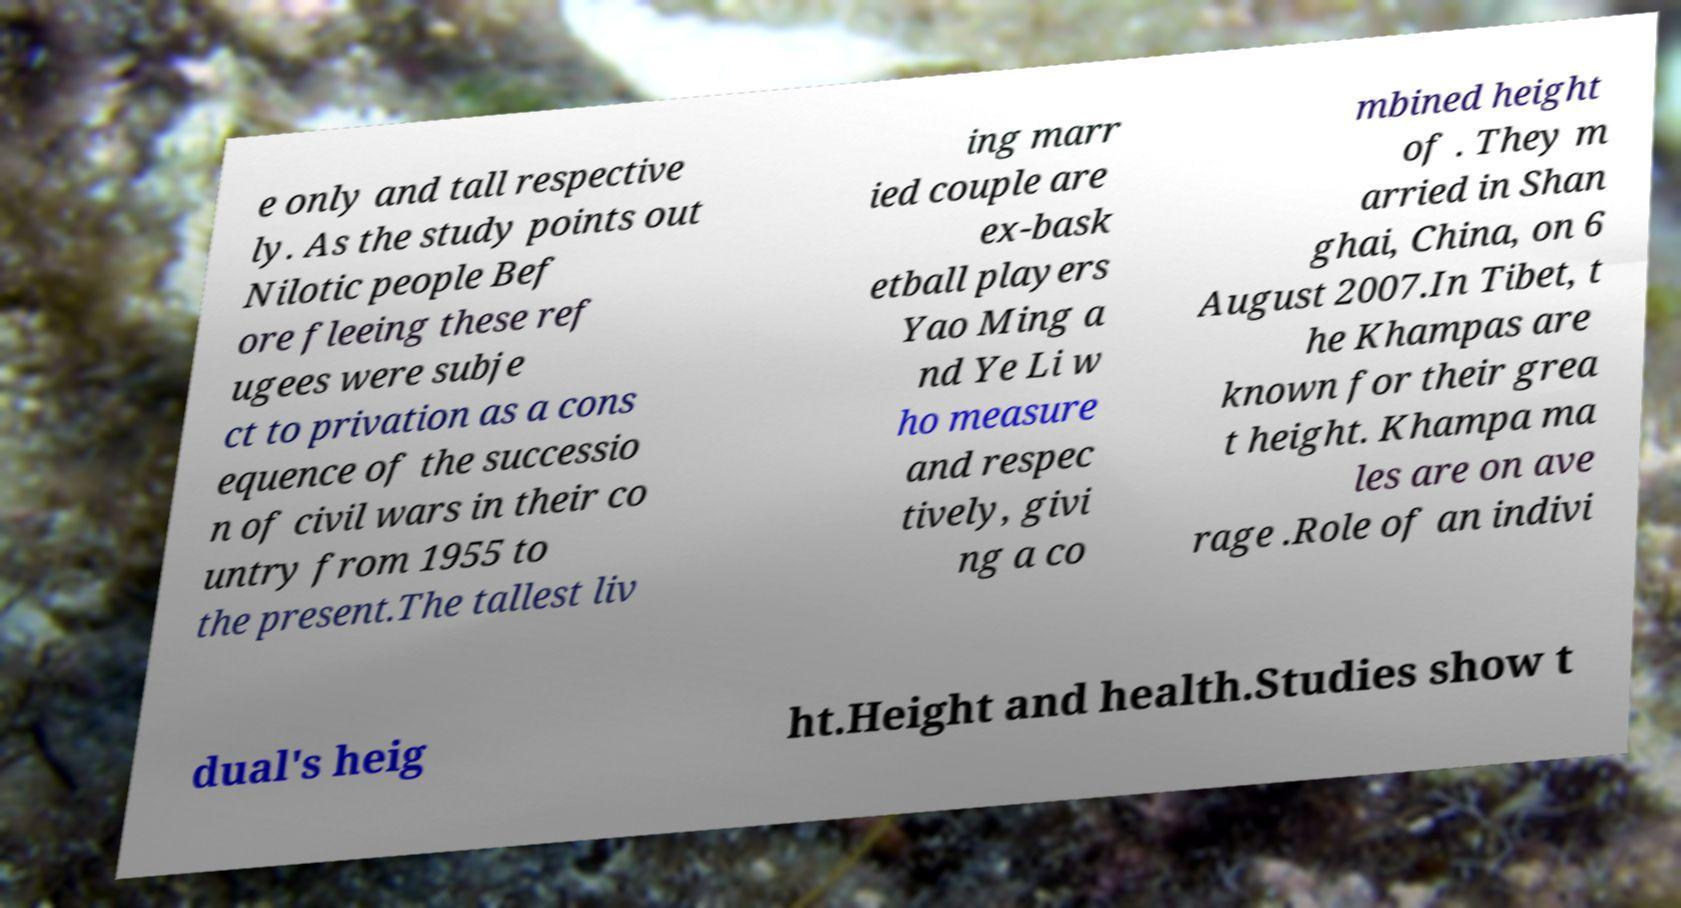What messages or text are displayed in this image? I need them in a readable, typed format. e only and tall respective ly. As the study points out Nilotic people Bef ore fleeing these ref ugees were subje ct to privation as a cons equence of the successio n of civil wars in their co untry from 1955 to the present.The tallest liv ing marr ied couple are ex-bask etball players Yao Ming a nd Ye Li w ho measure and respec tively, givi ng a co mbined height of . They m arried in Shan ghai, China, on 6 August 2007.In Tibet, t he Khampas are known for their grea t height. Khampa ma les are on ave rage .Role of an indivi dual's heig ht.Height and health.Studies show t 